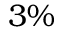<formula> <loc_0><loc_0><loc_500><loc_500>3 \%</formula> 